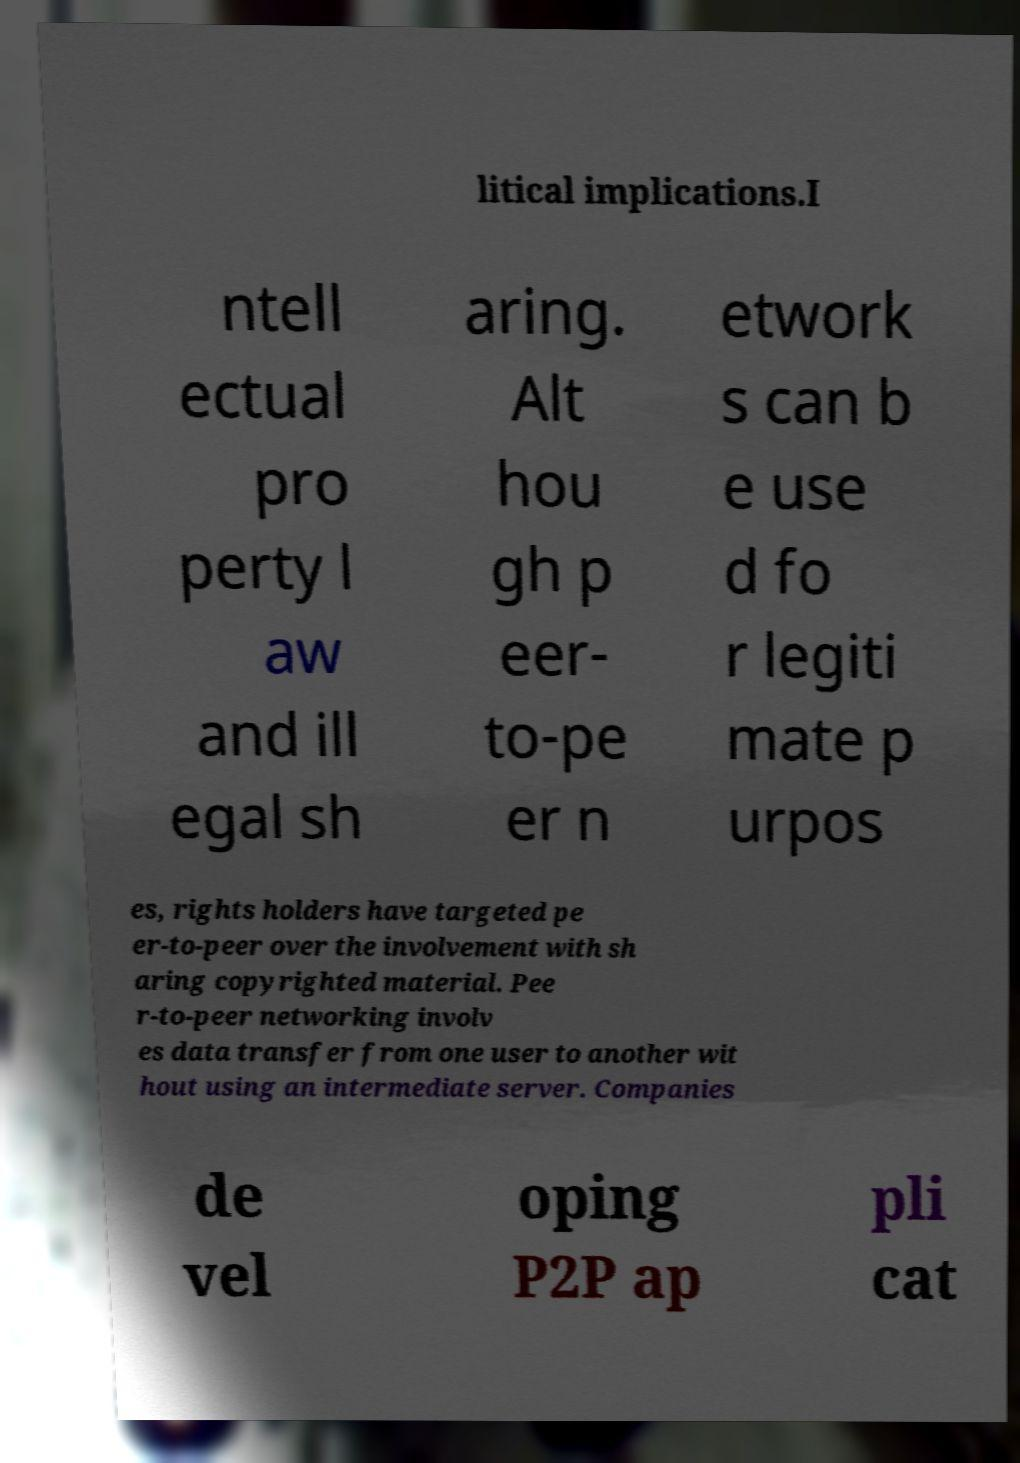I need the written content from this picture converted into text. Can you do that? litical implications.I ntell ectual pro perty l aw and ill egal sh aring. Alt hou gh p eer- to-pe er n etwork s can b e use d fo r legiti mate p urpos es, rights holders have targeted pe er-to-peer over the involvement with sh aring copyrighted material. Pee r-to-peer networking involv es data transfer from one user to another wit hout using an intermediate server. Companies de vel oping P2P ap pli cat 